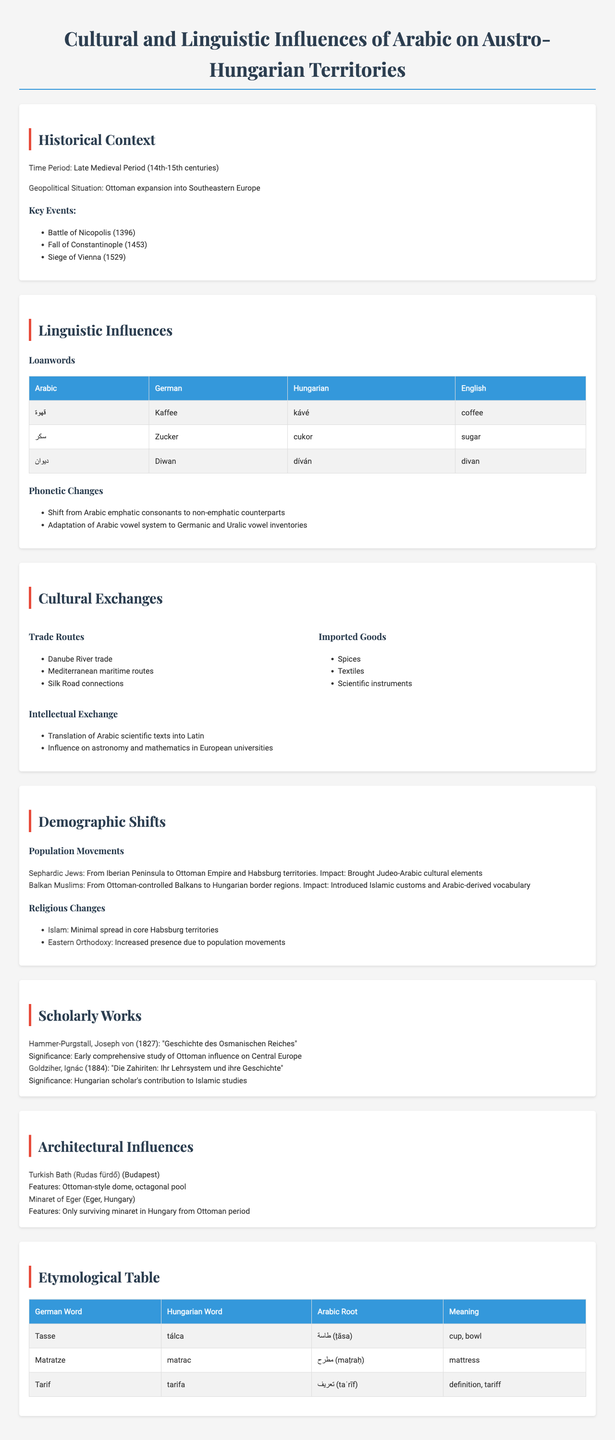What time period does the report cover? The report specifically mentions the Late Medieval Period, which spans the 14th to 15th centuries.
Answer: Late Medieval Period (14th-15th centuries) Which significant battle is mentioned as occurring in 1396? The document lists the Battle of Nicopolis among the key events during the Late Medieval Period.
Answer: Battle of Nicopolis What Arabic loanword is associated with 'coffee'? The report provides a direct correlation between the Arabic term "قهوة" and its counterparts in German, Hungarian, and English.
Answer: قهوة Who authored the work "Geschichte des Osmanischen Reiches"? The document specifies Joseph von Hammer-Purgstall as the author of this scholarly work related to Ottoman influence.
Answer: Joseph von Hammer-Purgstall What demographic shift is associated with the Sephardic Jews? The report details the movement of Sephardic Jews from the Iberian Peninsula to Ottoman Empire and Habsburg territories, noting their impact on cultural elements.
Answer: Brought Judeo-Arabic cultural elements Which architectural example mentioned in the report is located in Budapest? The document features the Turkish Bath (Rudas fürdő) as a notable architectural influence in Budapest.
Answer: Turkish Bath (Rudas fürdő) What is the Arabic root for the German word 'Matratze'? The report includes a table showing the Arabic origin for several words, specifically identifying 'مطرح' (maṭraḥ) as the root for 'Matratze'.
Answer: مطرح How many trade routes are listed in the document? The report mentions three trade routes as part of the cultural exchanges between the Arabic world and Austro-Hungarian territories.
Answer: Three What impact did Balkan Muslims have on the Hungarian border regions? The document notes that Balkan Muslims introduced Islamic customs and Arabic-derived vocabulary to the Hungarian border regions.
Answer: Introduced Islamic customs and Arabic-derived vocabulary What year was "Die Zahiriten: Ihr Lehrsystem und ihre Geschichte" published? The document states that Ignác Goldziher's work was published in 1884, contributing to Islamic studies.
Answer: 1884 